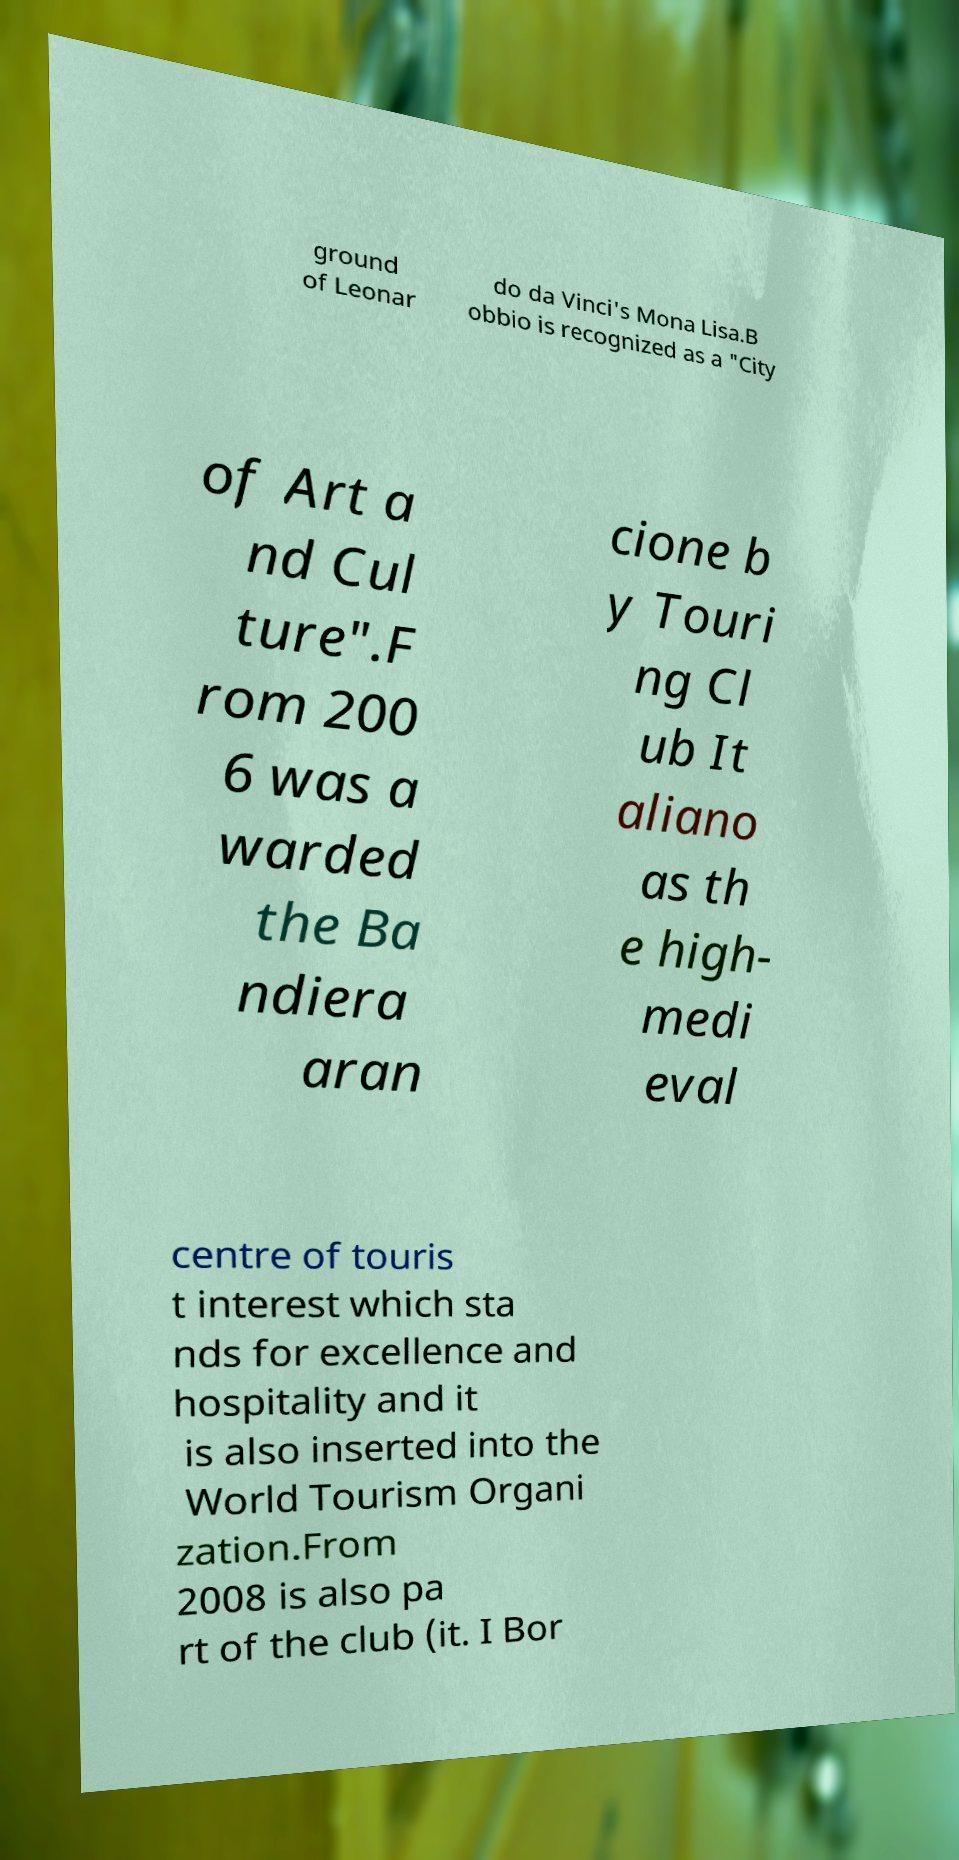What messages or text are displayed in this image? I need them in a readable, typed format. ground of Leonar do da Vinci's Mona Lisa.B obbio is recognized as a "City of Art a nd Cul ture".F rom 200 6 was a warded the Ba ndiera aran cione b y Touri ng Cl ub It aliano as th e high- medi eval centre of touris t interest which sta nds for excellence and hospitality and it is also inserted into the World Tourism Organi zation.From 2008 is also pa rt of the club (it. I Bor 